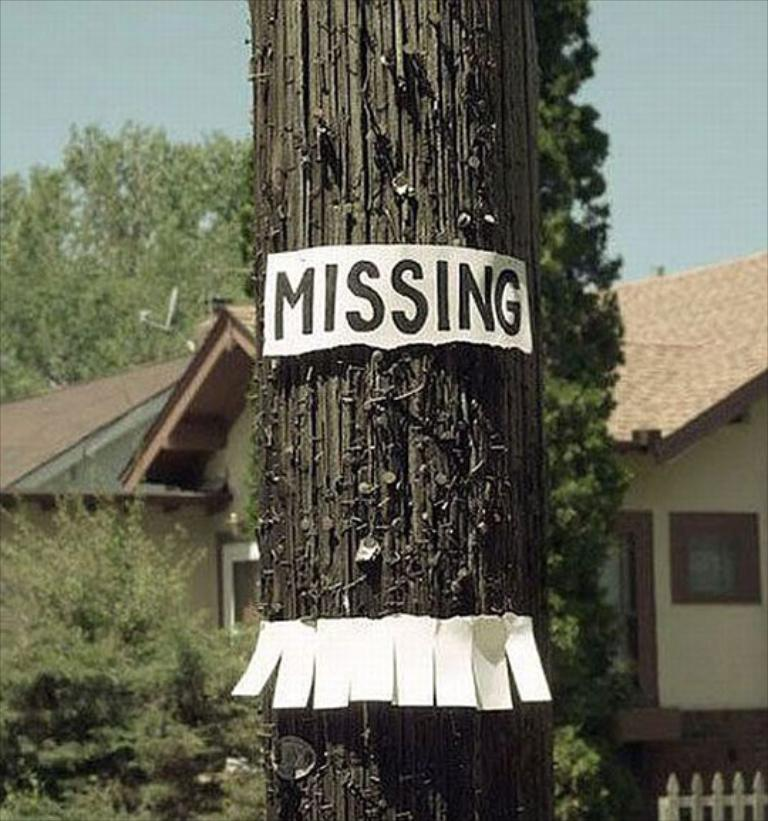What is located in the foreground of the image? There is a pole with a paper and some text in the foreground of the image. What can be seen in the background of the image? There is a building with windows and a roof, as well as a group of trees, in the background of the image. What is visible in the sky in the image? The sky is visible in the background of the image. How many rays are shining on the building in the image? There are no rays visible in the image; it only shows a pole with a paper and some text in the foreground, a building with windows and a roof, a group of trees, and the sky in the background. What type of fan is being used to cool the trees in the image? There are no fans present in the image; it only shows a pole with a paper and some text in the foreground, a building with windows and a roof, a group of trees, and the sky in the background. 